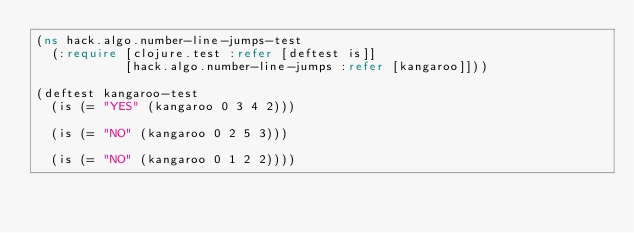<code> <loc_0><loc_0><loc_500><loc_500><_Clojure_>(ns hack.algo.number-line-jumps-test
  (:require [clojure.test :refer [deftest is]]
            [hack.algo.number-line-jumps :refer [kangaroo]]))

(deftest kangaroo-test
  (is (= "YES" (kangaroo 0 3 4 2)))

  (is (= "NO" (kangaroo 0 2 5 3)))

  (is (= "NO" (kangaroo 0 1 2 2))))
</code> 